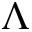Convert formula to latex. <formula><loc_0><loc_0><loc_500><loc_500>\Lambda</formula> 